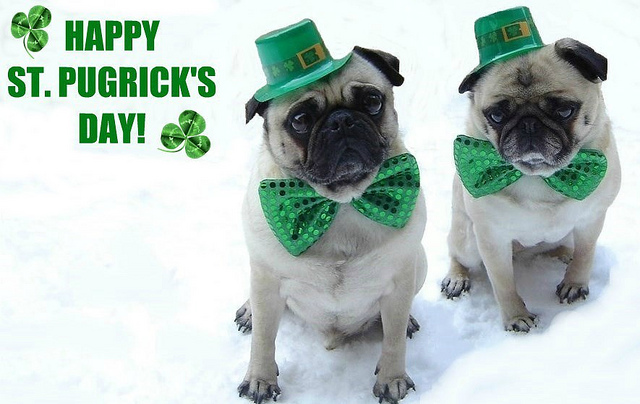Write a detailed description of the given image. The image shows two pugs dressed up in themed costumes for St. Patrick's Day. Both pugs are wearing bright green bow ties with black polka dots and small green top hats that resemble leprechaun hats. They are standing on what appears to be snow. The text 'HAPPY ST. PUGRICK'S DAY!' is displayed on the left side of the image with a decorative green shamrock. The pugs are looking towards the camera with a somewhat serious expression, adding to the festive spirit of the image. 